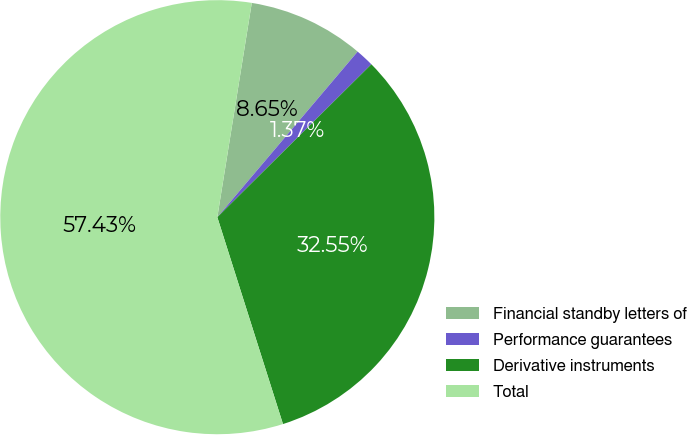Convert chart to OTSL. <chart><loc_0><loc_0><loc_500><loc_500><pie_chart><fcel>Financial standby letters of<fcel>Performance guarantees<fcel>Derivative instruments<fcel>Total<nl><fcel>8.65%<fcel>1.37%<fcel>32.55%<fcel>57.43%<nl></chart> 